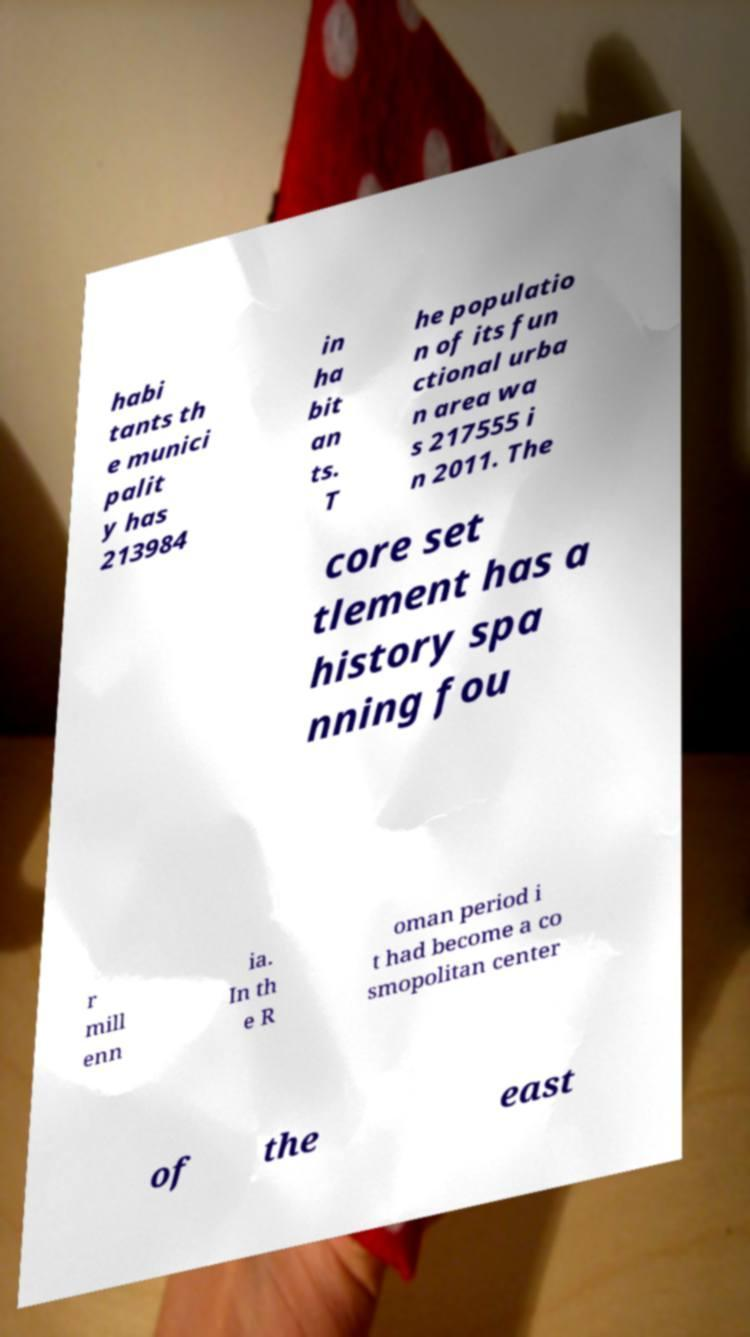Could you assist in decoding the text presented in this image and type it out clearly? habi tants th e munici palit y has 213984 in ha bit an ts. T he populatio n of its fun ctional urba n area wa s 217555 i n 2011. The core set tlement has a history spa nning fou r mill enn ia. In th e R oman period i t had become a co smopolitan center of the east 